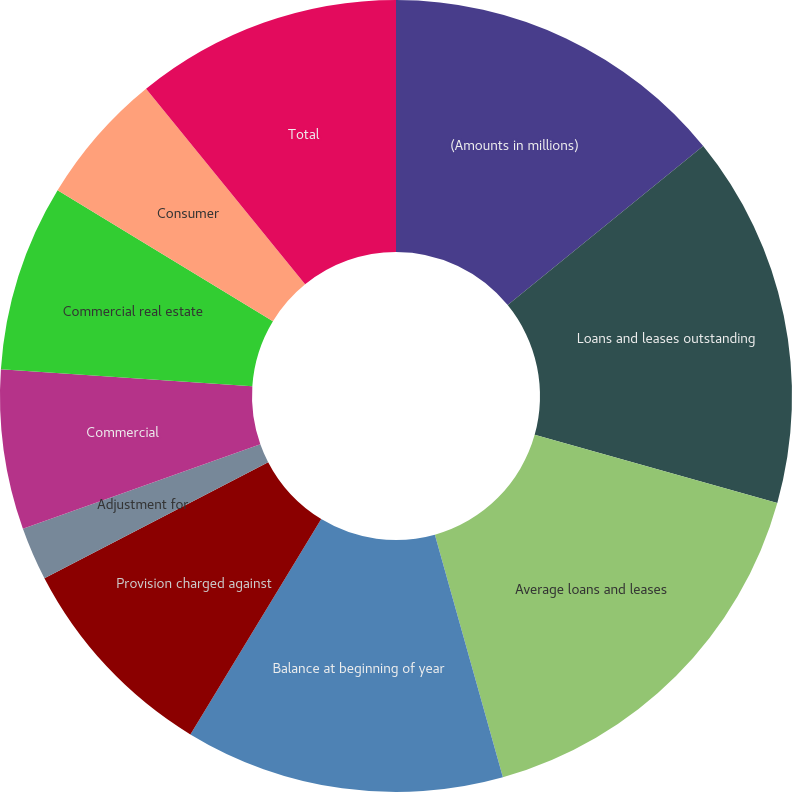Convert chart to OTSL. <chart><loc_0><loc_0><loc_500><loc_500><pie_chart><fcel>(Amounts in millions)<fcel>Loans and leases outstanding<fcel>Average loans and leases<fcel>Balance at beginning of year<fcel>Provision charged against<fcel>Adjustment for<fcel>Commercial<fcel>Commercial real estate<fcel>Consumer<fcel>Total<nl><fcel>14.13%<fcel>15.22%<fcel>16.3%<fcel>13.04%<fcel>8.7%<fcel>2.17%<fcel>6.52%<fcel>7.61%<fcel>5.44%<fcel>10.87%<nl></chart> 